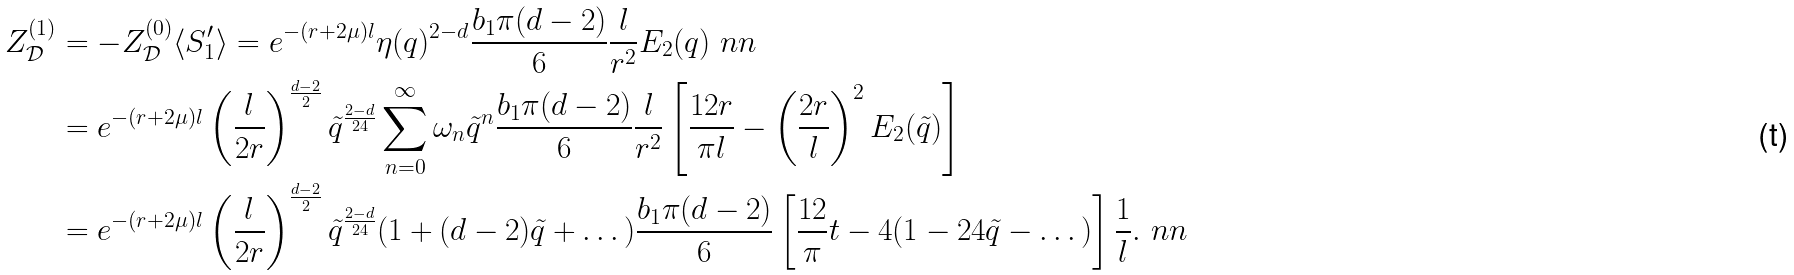Convert formula to latex. <formula><loc_0><loc_0><loc_500><loc_500>Z _ { \mathcal { D } } ^ { ( 1 ) } & = - Z _ { \mathcal { D } } ^ { ( 0 ) } \langle S ^ { \prime } _ { 1 } \rangle = e ^ { - ( r + 2 \mu ) l } \eta ( q ) ^ { 2 - d } \frac { b _ { 1 } \pi ( d - 2 ) } { 6 } \frac { l } { r ^ { 2 } } E _ { 2 } ( q ) \ n n \\ & = e ^ { - ( r + 2 \mu ) l } \left ( \frac { l } { 2 r } \right ) ^ { \frac { d - 2 } { 2 } } \tilde { q } ^ { \frac { 2 - d } { 2 4 } } \sum _ { n = 0 } ^ { \infty } \omega _ { n } \tilde { q } ^ { n } \frac { b _ { 1 } \pi ( d - 2 ) } { 6 } \frac { l } { r ^ { 2 } } \left [ \frac { 1 2 r } { \pi l } - \left ( \frac { 2 r } { l } \right ) ^ { 2 } E _ { 2 } ( \tilde { q } ) \right ] \\ & = e ^ { - ( r + 2 \mu ) l } \left ( \frac { l } { 2 r } \right ) ^ { \frac { d - 2 } { 2 } } \tilde { q } ^ { \frac { 2 - d } { 2 4 } } ( 1 + ( d - 2 ) \tilde { q } + \dots ) \frac { b _ { 1 } \pi ( d - 2 ) } { 6 } \left [ \frac { 1 2 } { \pi } t - 4 ( 1 - 2 4 \tilde { q } - \dots ) \right ] \frac { 1 } { l } . \ n n</formula> 